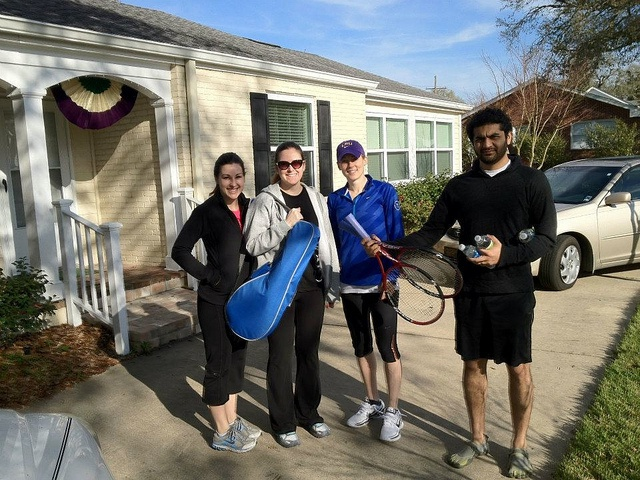Describe the objects in this image and their specific colors. I can see people in purple, black, gray, and tan tones, people in purple, black, lightgray, blue, and darkgray tones, people in purple, black, darkgray, gray, and tan tones, car in purple, black, beige, gray, and darkgray tones, and people in purple, black, navy, darkblue, and darkgray tones in this image. 